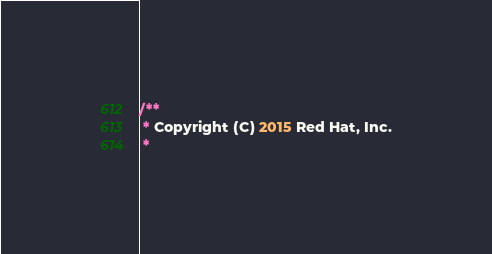Convert code to text. <code><loc_0><loc_0><loc_500><loc_500><_Go_>/**
 * Copyright (C) 2015 Red Hat, Inc.
 *</code> 